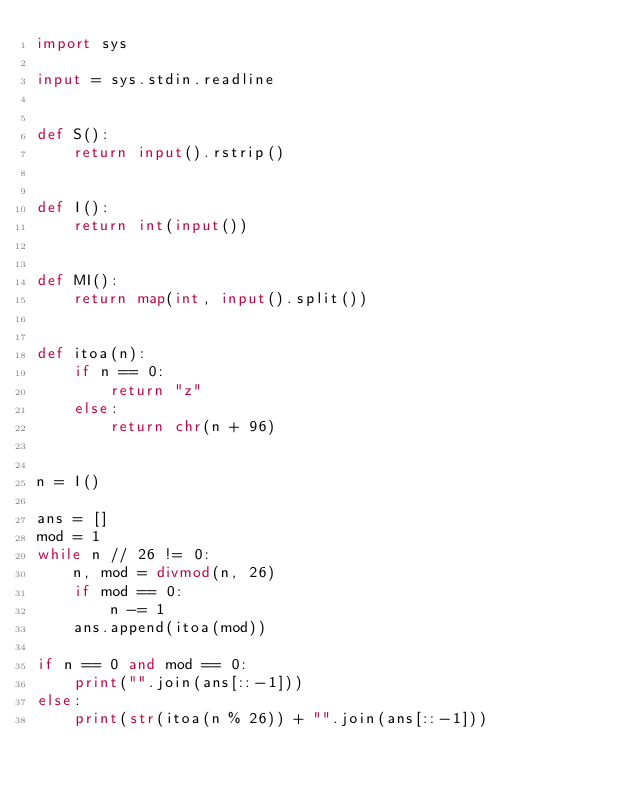Convert code to text. <code><loc_0><loc_0><loc_500><loc_500><_Python_>import sys

input = sys.stdin.readline


def S():
    return input().rstrip()


def I():
    return int(input())


def MI():
    return map(int, input().split())


def itoa(n):
    if n == 0:
        return "z"
    else:
        return chr(n + 96)


n = I()

ans = []
mod = 1
while n // 26 != 0:
    n, mod = divmod(n, 26)
    if mod == 0:
        n -= 1
    ans.append(itoa(mod))

if n == 0 and mod == 0:
    print("".join(ans[::-1]))
else:
    print(str(itoa(n % 26)) + "".join(ans[::-1]))
</code> 